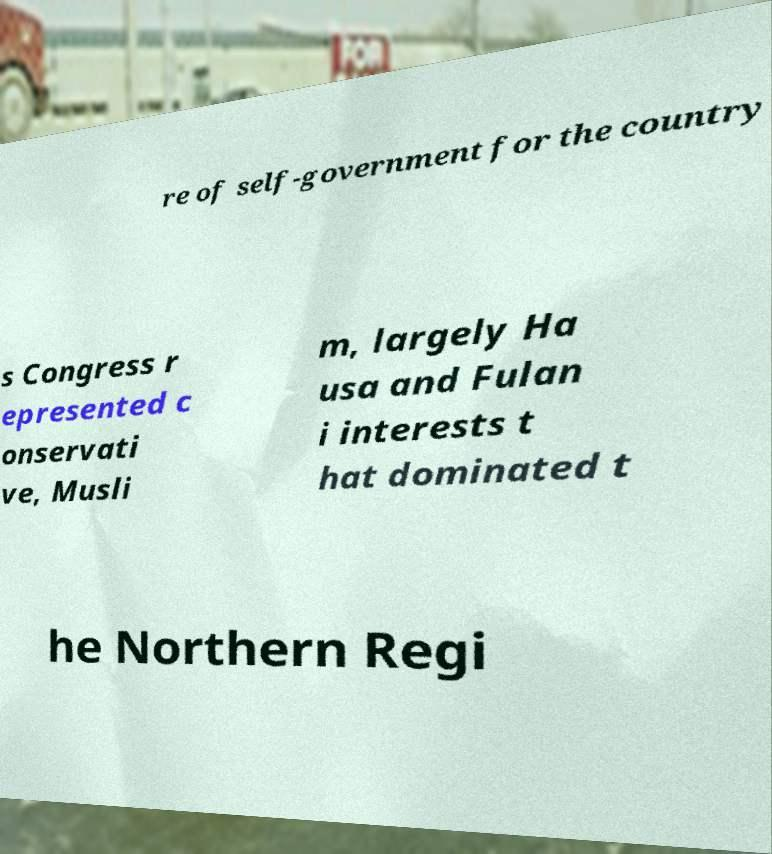What messages or text are displayed in this image? I need them in a readable, typed format. re of self-government for the country s Congress r epresented c onservati ve, Musli m, largely Ha usa and Fulan i interests t hat dominated t he Northern Regi 